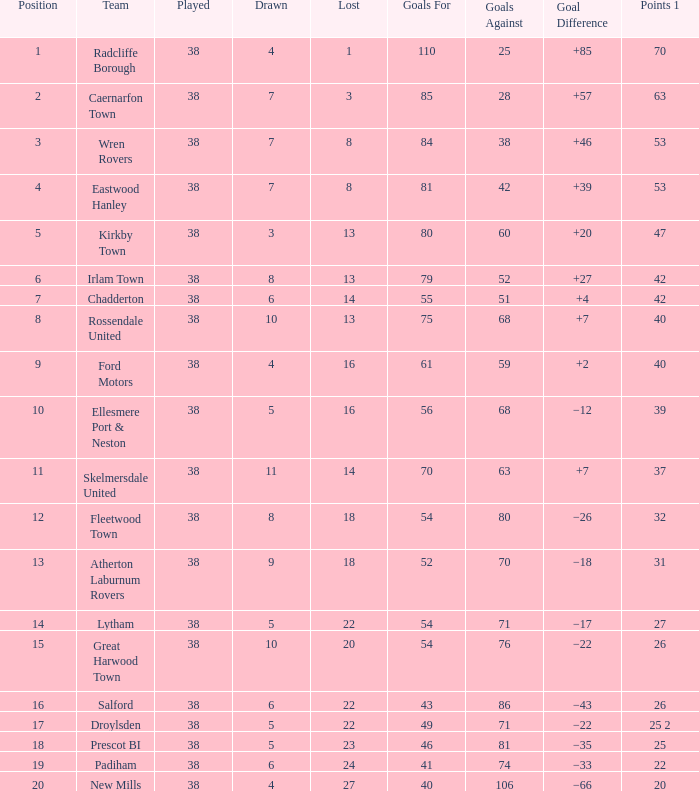Which Played has a Drawn of 4, and a Position of 9, and Goals Against larger than 59? None. 